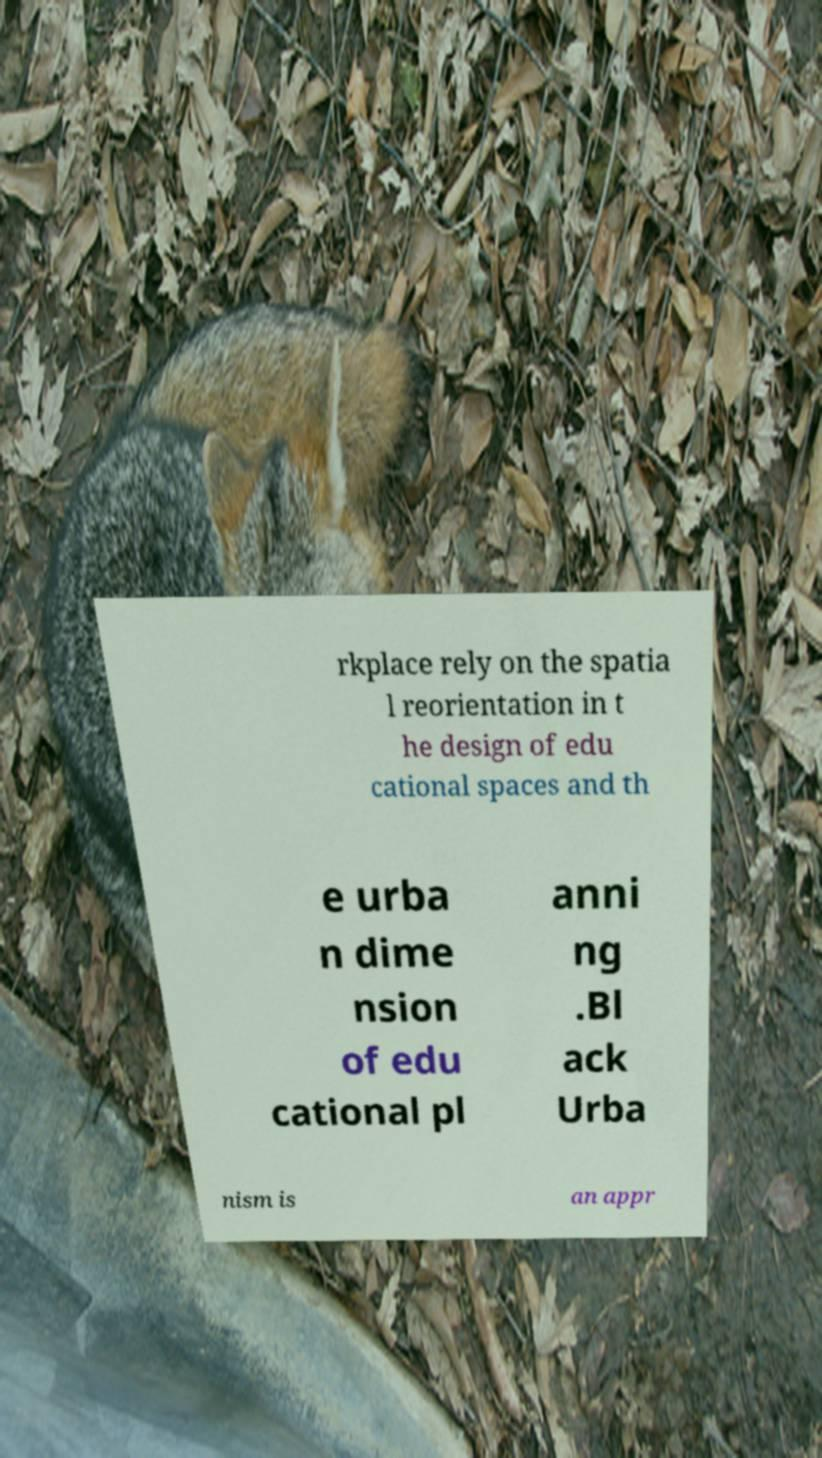There's text embedded in this image that I need extracted. Can you transcribe it verbatim? rkplace rely on the spatia l reorientation in t he design of edu cational spaces and th e urba n dime nsion of edu cational pl anni ng .Bl ack Urba nism is an appr 